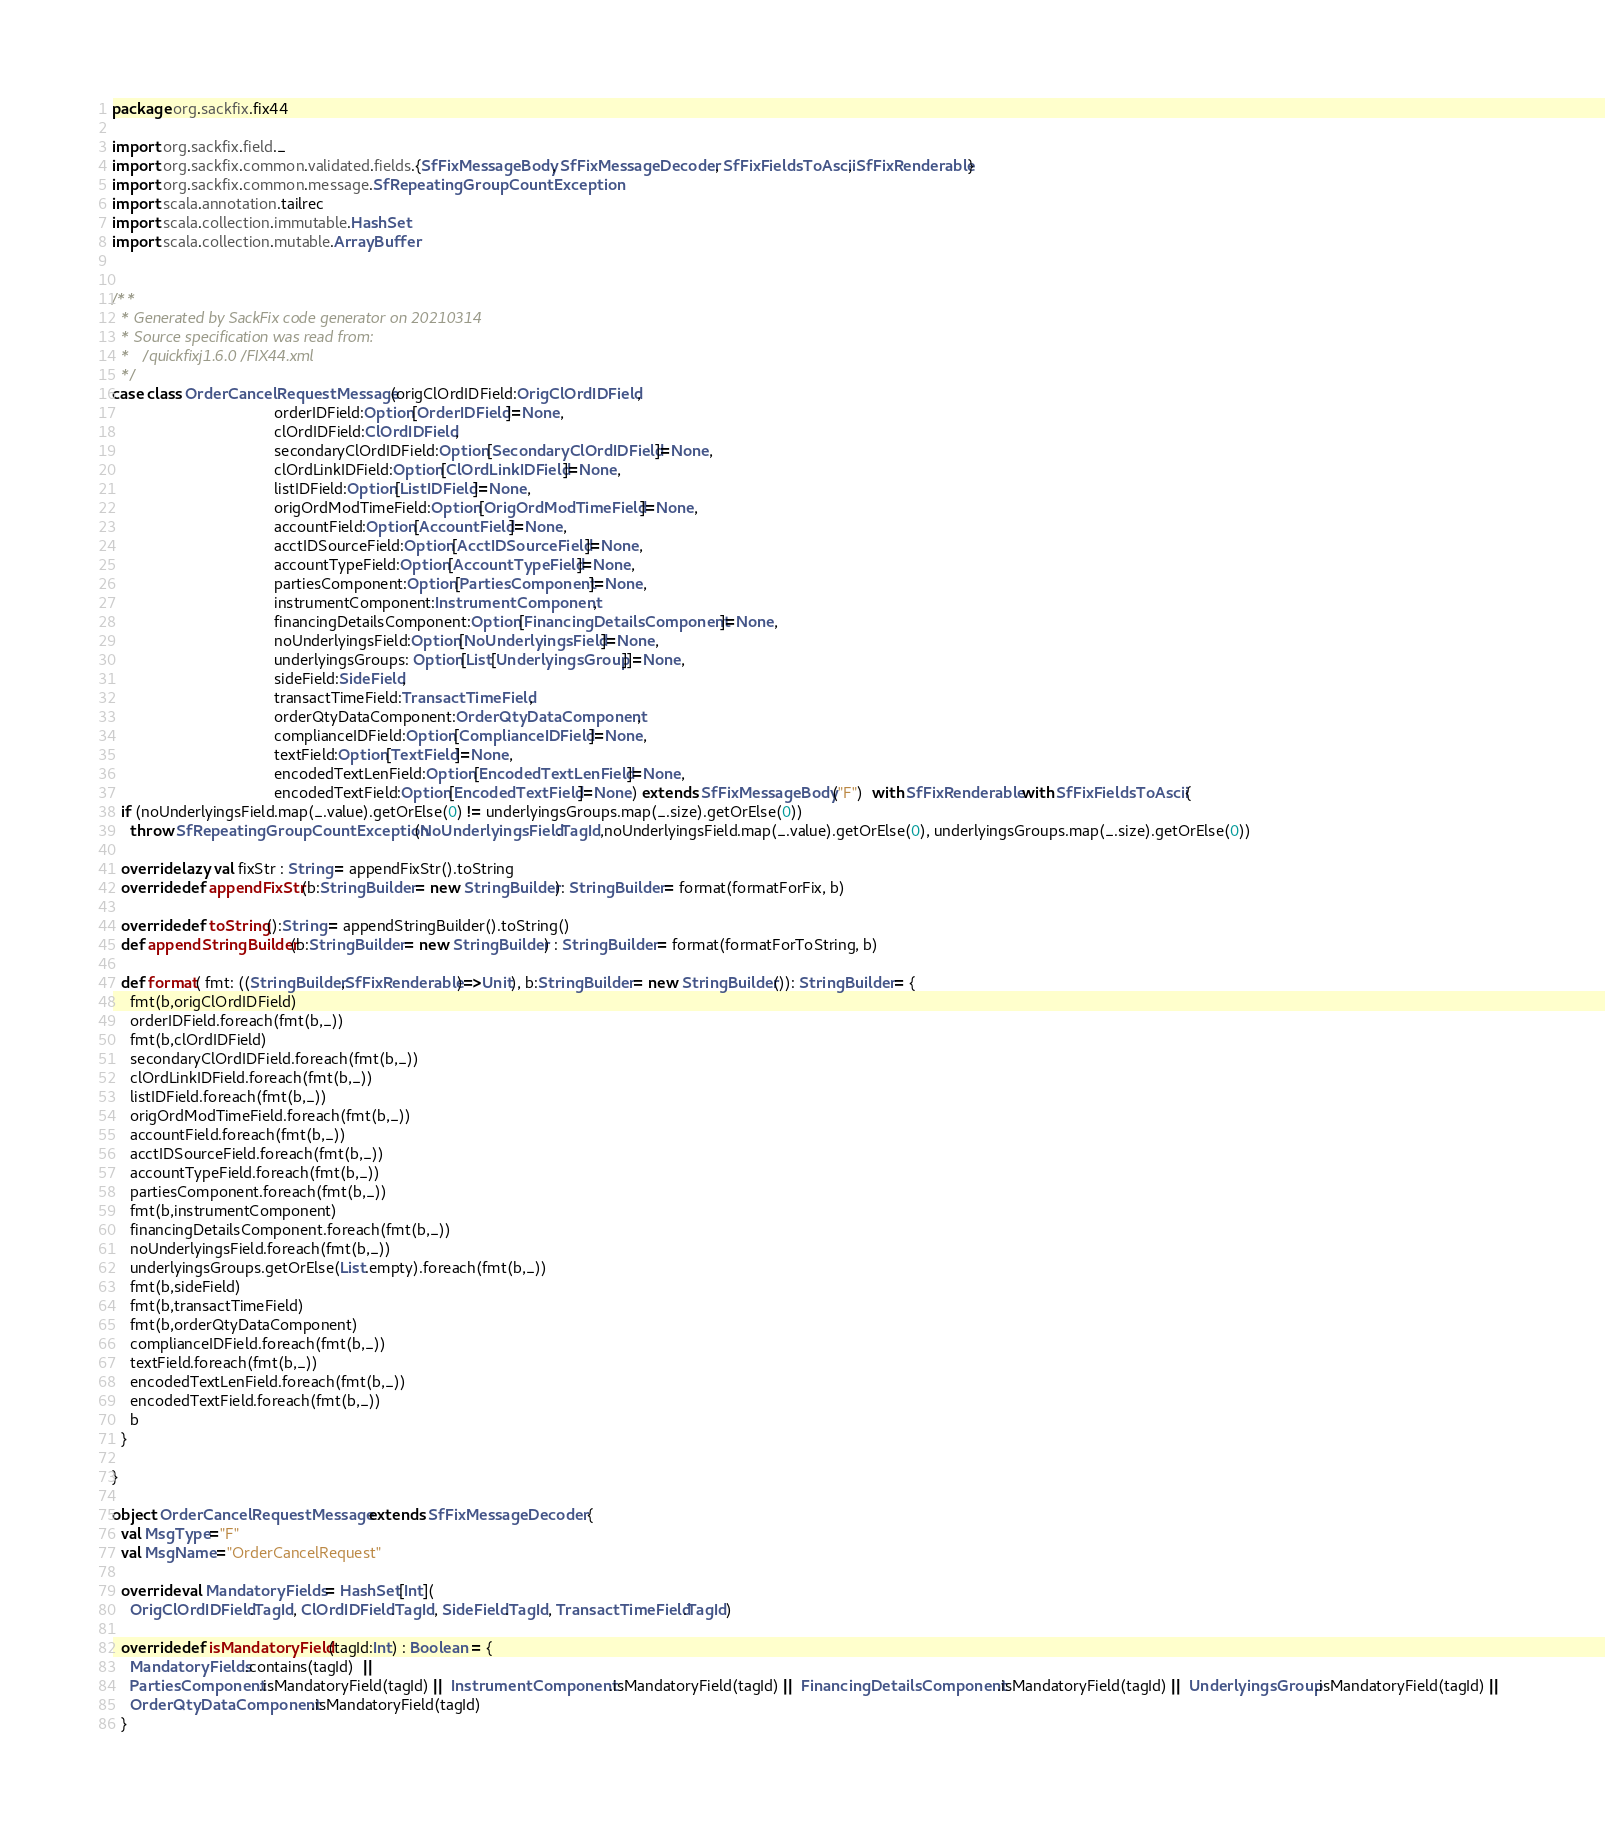<code> <loc_0><loc_0><loc_500><loc_500><_Scala_>package org.sackfix.fix44

import org.sackfix.field._
import org.sackfix.common.validated.fields.{SfFixMessageBody, SfFixMessageDecoder, SfFixFieldsToAscii, SfFixRenderable}
import org.sackfix.common.message.SfRepeatingGroupCountException
import scala.annotation.tailrec
import scala.collection.immutable.HashSet
import scala.collection.mutable.ArrayBuffer


/**
  * Generated by SackFix code generator on 20210314
  * Source specification was read from:
  *   /quickfixj1.6.0/FIX44.xml
  */
case class OrderCancelRequestMessage(origClOrdIDField:OrigClOrdIDField,
                                     orderIDField:Option[OrderIDField]=None,
                                     clOrdIDField:ClOrdIDField,
                                     secondaryClOrdIDField:Option[SecondaryClOrdIDField]=None,
                                     clOrdLinkIDField:Option[ClOrdLinkIDField]=None,
                                     listIDField:Option[ListIDField]=None,
                                     origOrdModTimeField:Option[OrigOrdModTimeField]=None,
                                     accountField:Option[AccountField]=None,
                                     acctIDSourceField:Option[AcctIDSourceField]=None,
                                     accountTypeField:Option[AccountTypeField]=None,
                                     partiesComponent:Option[PartiesComponent]=None,
                                     instrumentComponent:InstrumentComponent,
                                     financingDetailsComponent:Option[FinancingDetailsComponent]=None,
                                     noUnderlyingsField:Option[NoUnderlyingsField]=None,
                                     underlyingsGroups: Option[List[UnderlyingsGroup]]=None,
                                     sideField:SideField,
                                     transactTimeField:TransactTimeField,
                                     orderQtyDataComponent:OrderQtyDataComponent,
                                     complianceIDField:Option[ComplianceIDField]=None,
                                     textField:Option[TextField]=None,
                                     encodedTextLenField:Option[EncodedTextLenField]=None,
                                     encodedTextField:Option[EncodedTextField]=None) extends SfFixMessageBody("F")  with SfFixRenderable with SfFixFieldsToAscii {
  if (noUnderlyingsField.map(_.value).getOrElse(0) != underlyingsGroups.map(_.size).getOrElse(0))
    throw SfRepeatingGroupCountException(NoUnderlyingsField.TagId,noUnderlyingsField.map(_.value).getOrElse(0), underlyingsGroups.map(_.size).getOrElse(0))

  override lazy val fixStr : String = appendFixStr().toString
  override def appendFixStr(b:StringBuilder = new StringBuilder): StringBuilder = format(formatForFix, b)

  override def toString():String = appendStringBuilder().toString()
  def appendStringBuilder(b:StringBuilder = new StringBuilder) : StringBuilder = format(formatForToString, b)

  def format( fmt: ((StringBuilder,SfFixRenderable)=>Unit), b:StringBuilder = new StringBuilder()): StringBuilder = {
    fmt(b,origClOrdIDField)
    orderIDField.foreach(fmt(b,_))
    fmt(b,clOrdIDField)
    secondaryClOrdIDField.foreach(fmt(b,_))
    clOrdLinkIDField.foreach(fmt(b,_))
    listIDField.foreach(fmt(b,_))
    origOrdModTimeField.foreach(fmt(b,_))
    accountField.foreach(fmt(b,_))
    acctIDSourceField.foreach(fmt(b,_))
    accountTypeField.foreach(fmt(b,_))
    partiesComponent.foreach(fmt(b,_))
    fmt(b,instrumentComponent)
    financingDetailsComponent.foreach(fmt(b,_))
    noUnderlyingsField.foreach(fmt(b,_))
    underlyingsGroups.getOrElse(List.empty).foreach(fmt(b,_))
    fmt(b,sideField)
    fmt(b,transactTimeField)
    fmt(b,orderQtyDataComponent)
    complianceIDField.foreach(fmt(b,_))
    textField.foreach(fmt(b,_))
    encodedTextLenField.foreach(fmt(b,_))
    encodedTextField.foreach(fmt(b,_))
    b
  }

}
     
object OrderCancelRequestMessage extends SfFixMessageDecoder {
  val MsgType="F"
  val MsgName="OrderCancelRequest"
             
  override val MandatoryFields = HashSet[Int](
    OrigClOrdIDField.TagId, ClOrdIDField.TagId, SideField.TagId, TransactTimeField.TagId)

  override def isMandatoryField(tagId:Int) : Boolean = {
    MandatoryFields.contains(tagId)  || 
    PartiesComponent.isMandatoryField(tagId) || InstrumentComponent.isMandatoryField(tagId) || FinancingDetailsComponent.isMandatoryField(tagId) || UnderlyingsGroup.isMandatoryField(tagId) || 
    OrderQtyDataComponent.isMandatoryField(tagId)
  }
</code> 